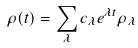<formula> <loc_0><loc_0><loc_500><loc_500>\rho ( t ) = \sum _ { \lambda } c _ { \lambda } e ^ { \lambda t } \rho _ { \lambda }</formula> 